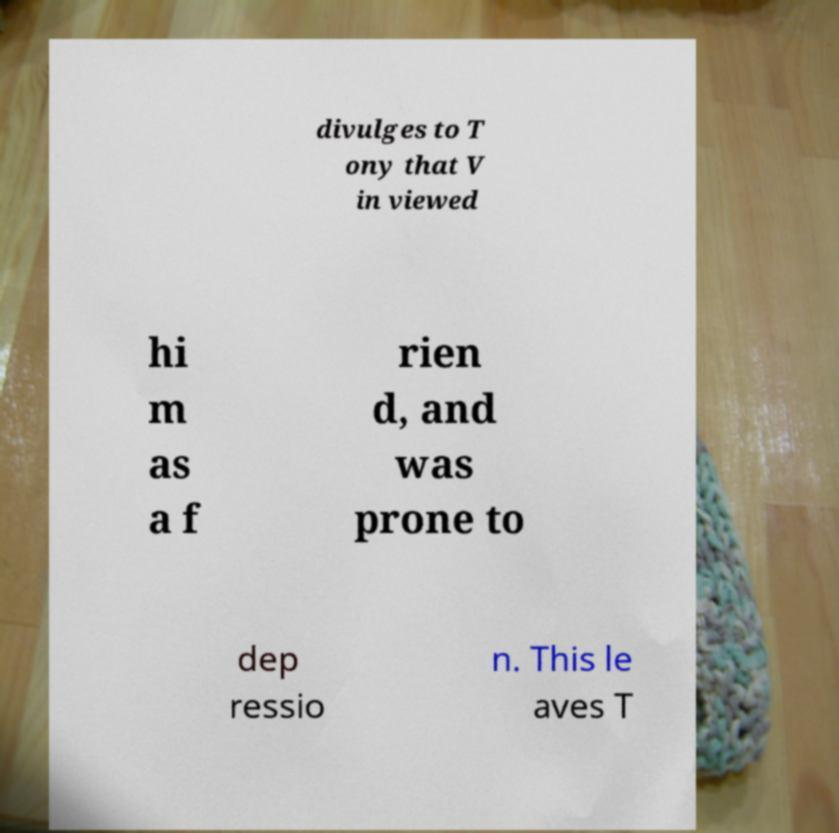Please identify and transcribe the text found in this image. divulges to T ony that V in viewed hi m as a f rien d, and was prone to dep ressio n. This le aves T 